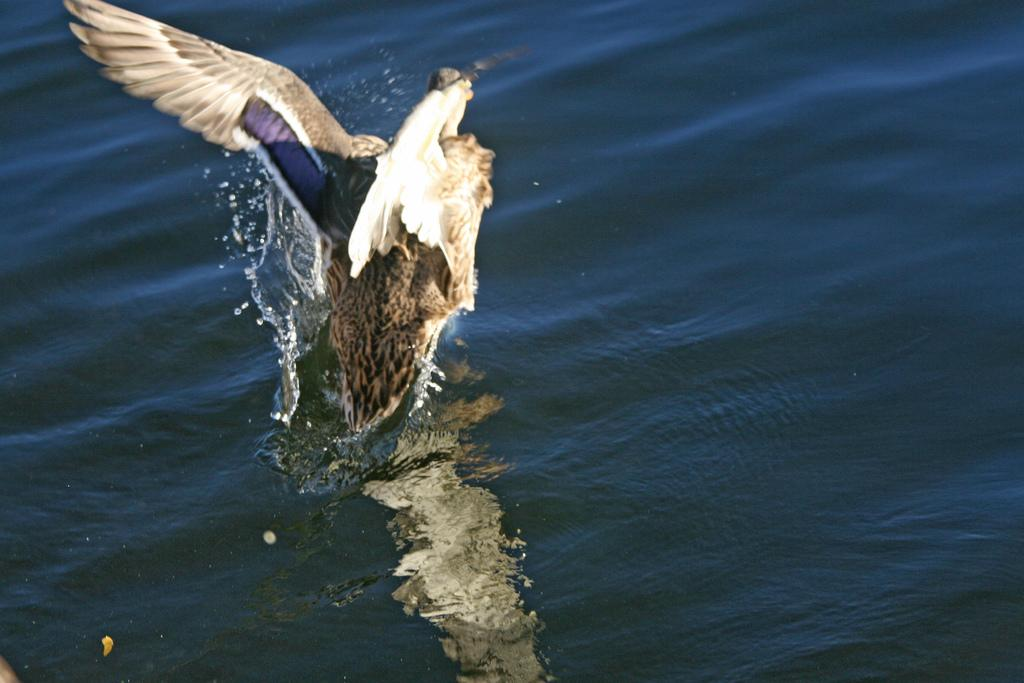What type of animal can be seen in the image? There is a bird in the image. Where is the bird located in the image? The bird is in the air. What can be seen in the background of the image? There is water visible in the image. What colors can be observed on the bird? The bird has brown, white, and black colors. What type of tooth can be seen in the image? There is no tooth present in the image; it features a bird in the air with water visible in the background. 